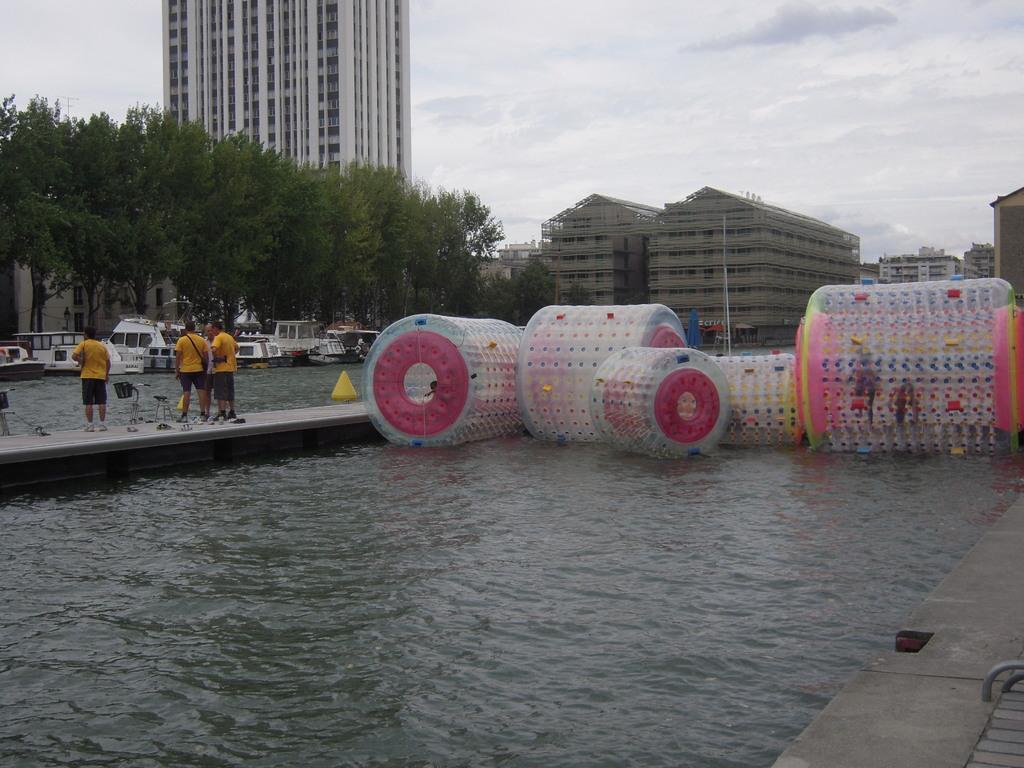How would you summarize this image in a sentence or two? In this image I see the water, platforms over here and I see few people who are standing and I see that they're wearing same dress and I see few colorful things over here. In the background I see the trees, buildings, boats and the sky. 